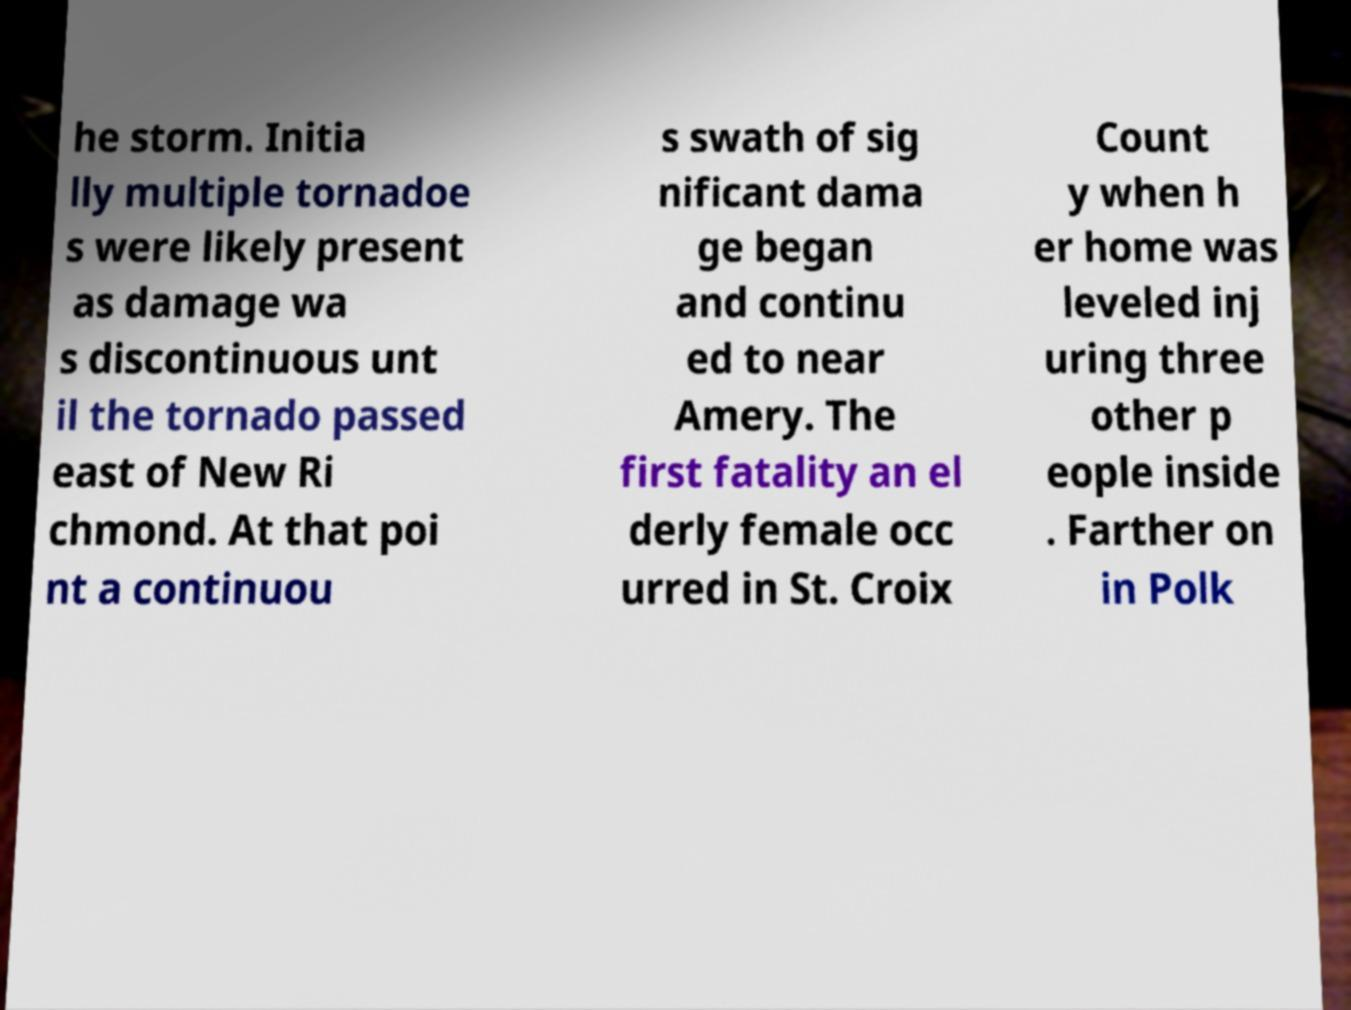I need the written content from this picture converted into text. Can you do that? he storm. Initia lly multiple tornadoe s were likely present as damage wa s discontinuous unt il the tornado passed east of New Ri chmond. At that poi nt a continuou s swath of sig nificant dama ge began and continu ed to near Amery. The first fatality an el derly female occ urred in St. Croix Count y when h er home was leveled inj uring three other p eople inside . Farther on in Polk 